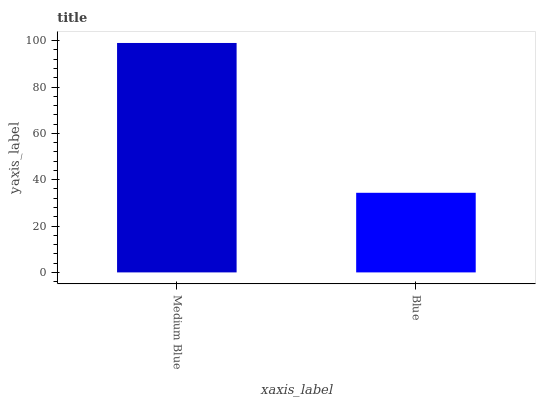Is Blue the maximum?
Answer yes or no. No. Is Medium Blue greater than Blue?
Answer yes or no. Yes. Is Blue less than Medium Blue?
Answer yes or no. Yes. Is Blue greater than Medium Blue?
Answer yes or no. No. Is Medium Blue less than Blue?
Answer yes or no. No. Is Medium Blue the high median?
Answer yes or no. Yes. Is Blue the low median?
Answer yes or no. Yes. Is Blue the high median?
Answer yes or no. No. Is Medium Blue the low median?
Answer yes or no. No. 